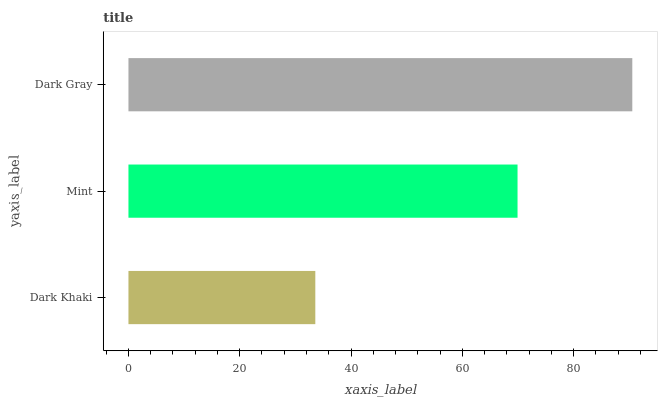Is Dark Khaki the minimum?
Answer yes or no. Yes. Is Dark Gray the maximum?
Answer yes or no. Yes. Is Mint the minimum?
Answer yes or no. No. Is Mint the maximum?
Answer yes or no. No. Is Mint greater than Dark Khaki?
Answer yes or no. Yes. Is Dark Khaki less than Mint?
Answer yes or no. Yes. Is Dark Khaki greater than Mint?
Answer yes or no. No. Is Mint less than Dark Khaki?
Answer yes or no. No. Is Mint the high median?
Answer yes or no. Yes. Is Mint the low median?
Answer yes or no. Yes. Is Dark Khaki the high median?
Answer yes or no. No. Is Dark Khaki the low median?
Answer yes or no. No. 